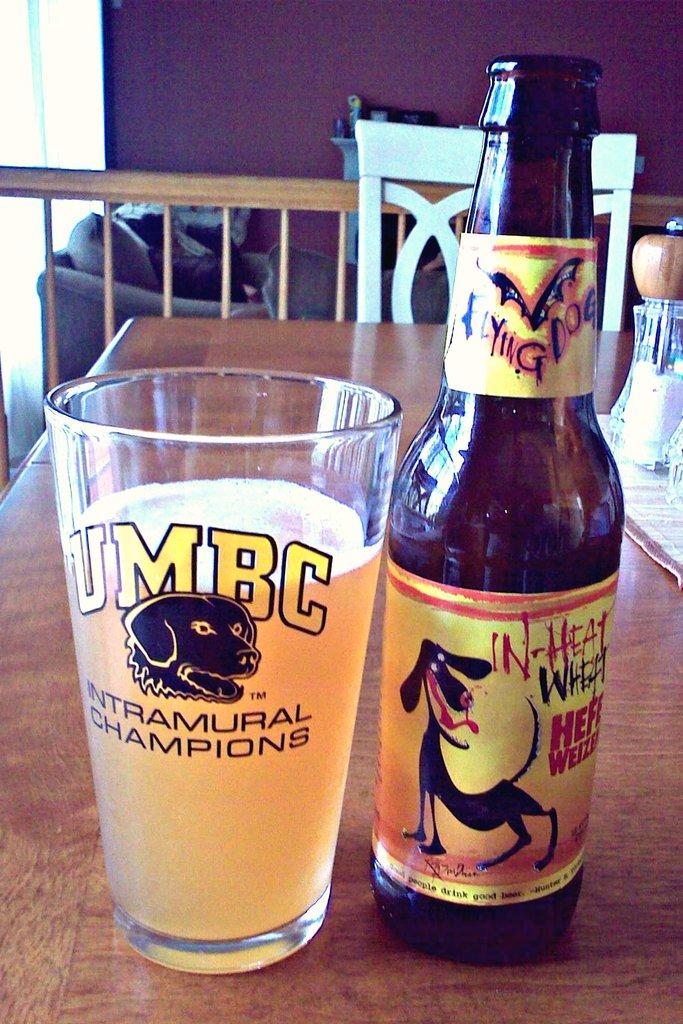<image>
Render a clear and concise summary of the photo. a UMBC glass that has a dog on it 